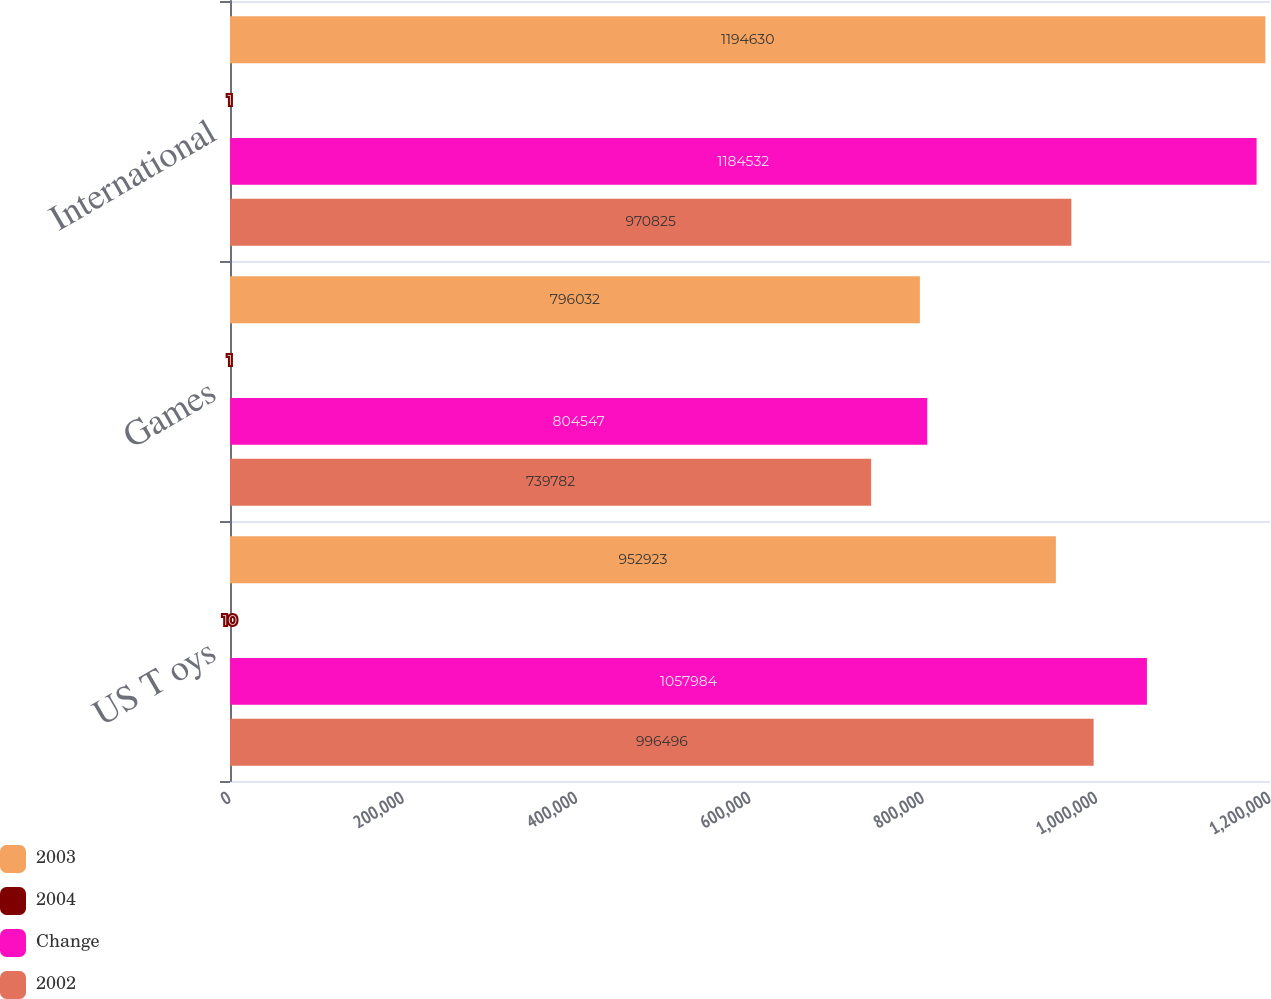Convert chart to OTSL. <chart><loc_0><loc_0><loc_500><loc_500><stacked_bar_chart><ecel><fcel>US T oys<fcel>Games<fcel>International<nl><fcel>2003<fcel>952923<fcel>796032<fcel>1.19463e+06<nl><fcel>2004<fcel>10<fcel>1<fcel>1<nl><fcel>Change<fcel>1.05798e+06<fcel>804547<fcel>1.18453e+06<nl><fcel>2002<fcel>996496<fcel>739782<fcel>970825<nl></chart> 